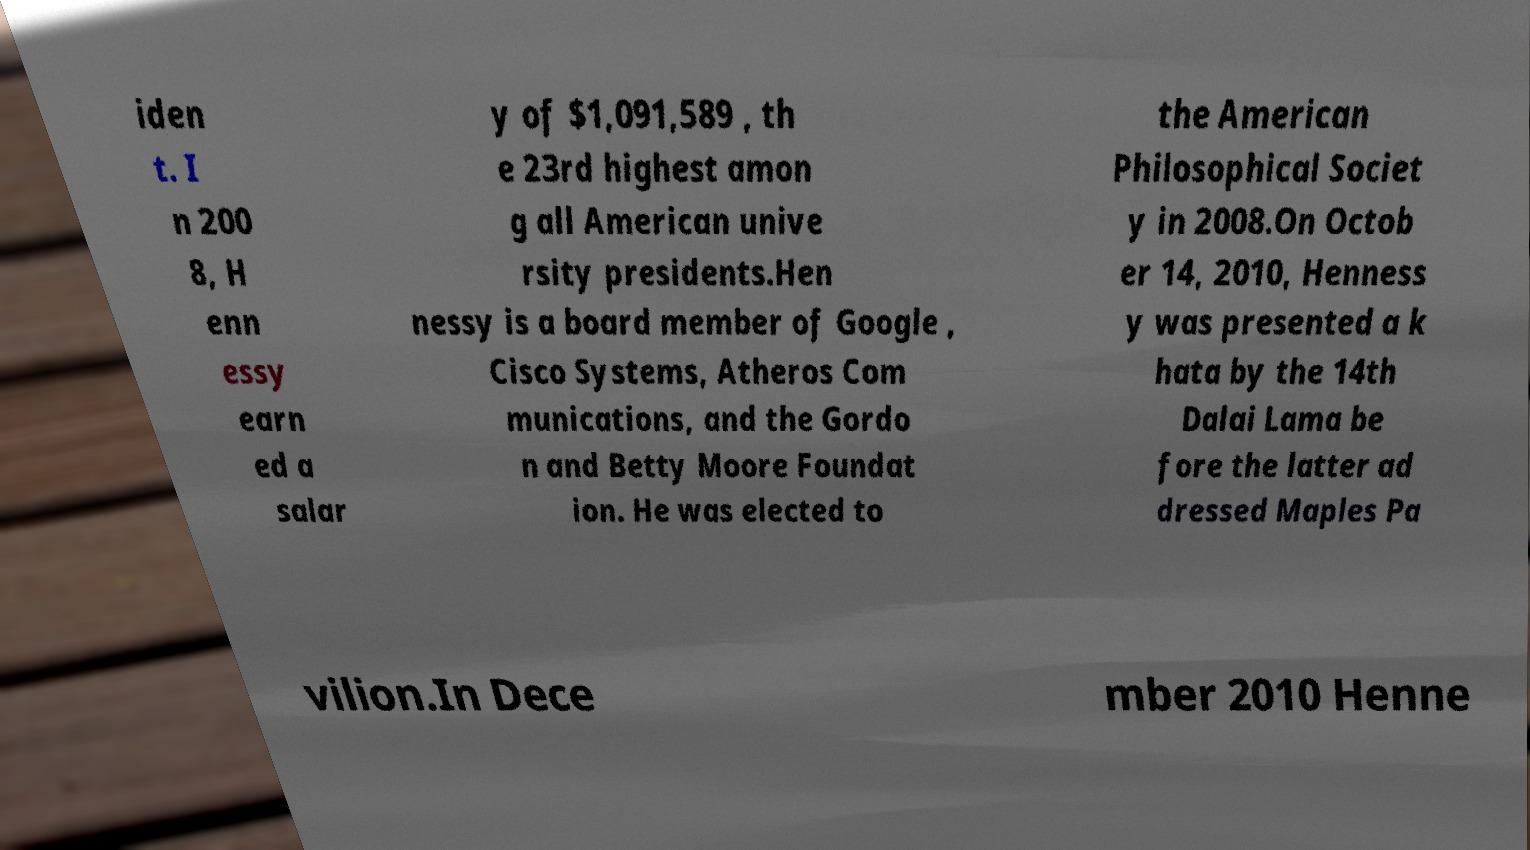There's text embedded in this image that I need extracted. Can you transcribe it verbatim? iden t. I n 200 8, H enn essy earn ed a salar y of $1,091,589 , th e 23rd highest amon g all American unive rsity presidents.Hen nessy is a board member of Google , Cisco Systems, Atheros Com munications, and the Gordo n and Betty Moore Foundat ion. He was elected to the American Philosophical Societ y in 2008.On Octob er 14, 2010, Henness y was presented a k hata by the 14th Dalai Lama be fore the latter ad dressed Maples Pa vilion.In Dece mber 2010 Henne 